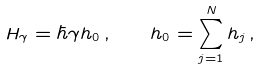Convert formula to latex. <formula><loc_0><loc_0><loc_500><loc_500>H _ { \gamma } = \hbar { \gamma } h _ { 0 } \, , \quad h _ { 0 } = \sum _ { j = 1 } ^ { N } h _ { j } \, ,</formula> 